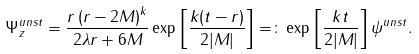Convert formula to latex. <formula><loc_0><loc_0><loc_500><loc_500>\Psi _ { z } ^ { u n s t } = \frac { r \left ( r - 2 M \right ) ^ { k } } { 2 \lambda r + 6 M } \exp \left [ \frac { k ( t - r ) } { 2 | M | } \right ] = \colon \exp \left [ \frac { k t } { 2 | M | } \right ] \psi ^ { u n s t } .</formula> 